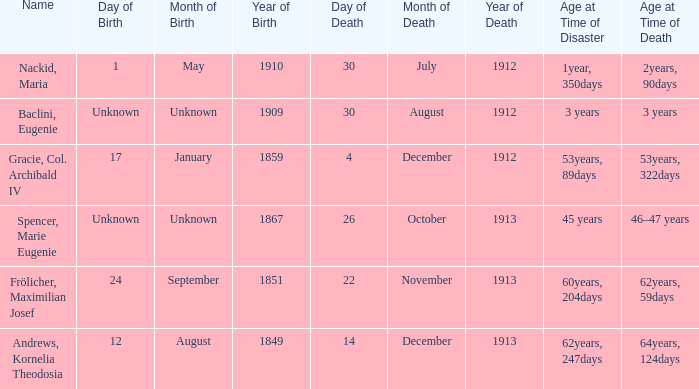What is the name of the person born in 1909? Baclini, Eugenie. 